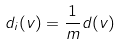<formula> <loc_0><loc_0><loc_500><loc_500>d _ { i } ( v ) = \frac { 1 } { m } d ( v )</formula> 